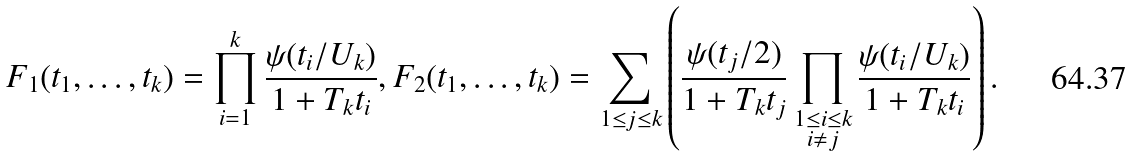Convert formula to latex. <formula><loc_0><loc_0><loc_500><loc_500>F _ { 1 } ( t _ { 1 } , \dots , t _ { k } ) = \prod _ { i = 1 } ^ { k } \frac { \psi ( t _ { i } / U _ { k } ) } { 1 + T _ { k } t _ { i } } , F _ { 2 } ( t _ { 1 } , \dots , t _ { k } ) = \sum _ { 1 \leq j \leq k } \left ( \frac { \psi ( t _ { j } / 2 ) } { 1 + T _ { k } t _ { j } } \prod _ { \substack { 1 \leq i \leq k \\ i \ne j } } \frac { \psi ( t _ { i } / U _ { k } ) } { 1 + T _ { k } t _ { i } } \right ) .</formula> 